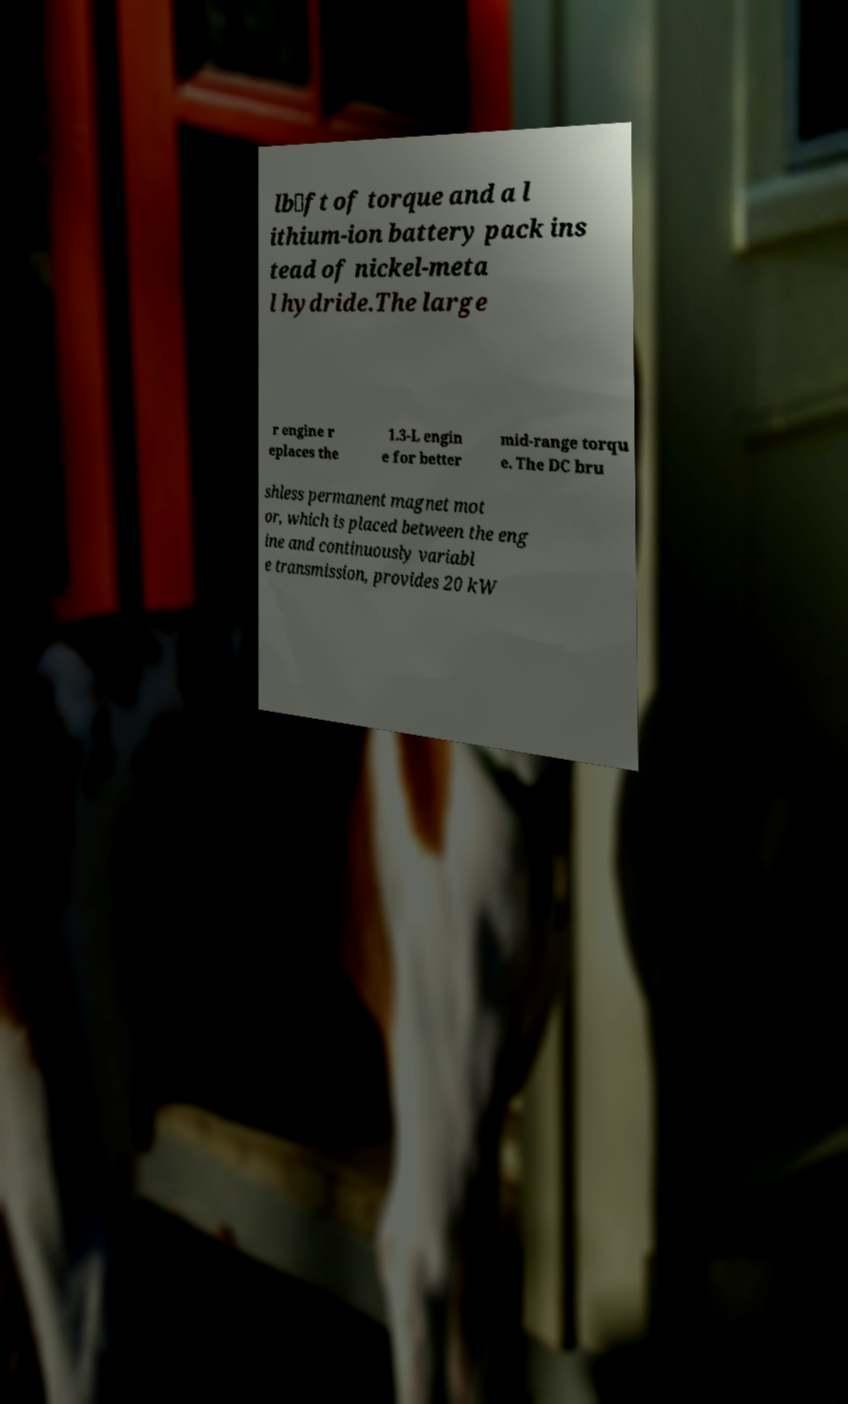Please identify and transcribe the text found in this image. lb⋅ft of torque and a l ithium-ion battery pack ins tead of nickel-meta l hydride.The large r engine r eplaces the 1.3-L engin e for better mid-range torqu e. The DC bru shless permanent magnet mot or, which is placed between the eng ine and continuously variabl e transmission, provides 20 kW 